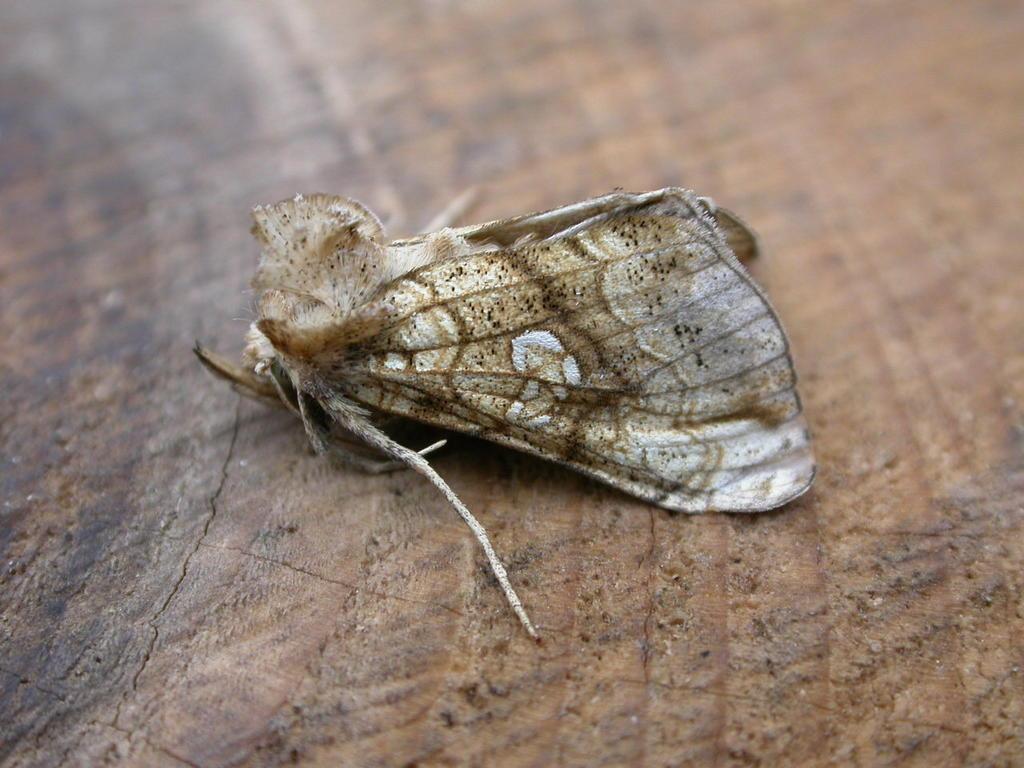How would you summarize this image in a sentence or two? In this picture I can see a moth on an object. 